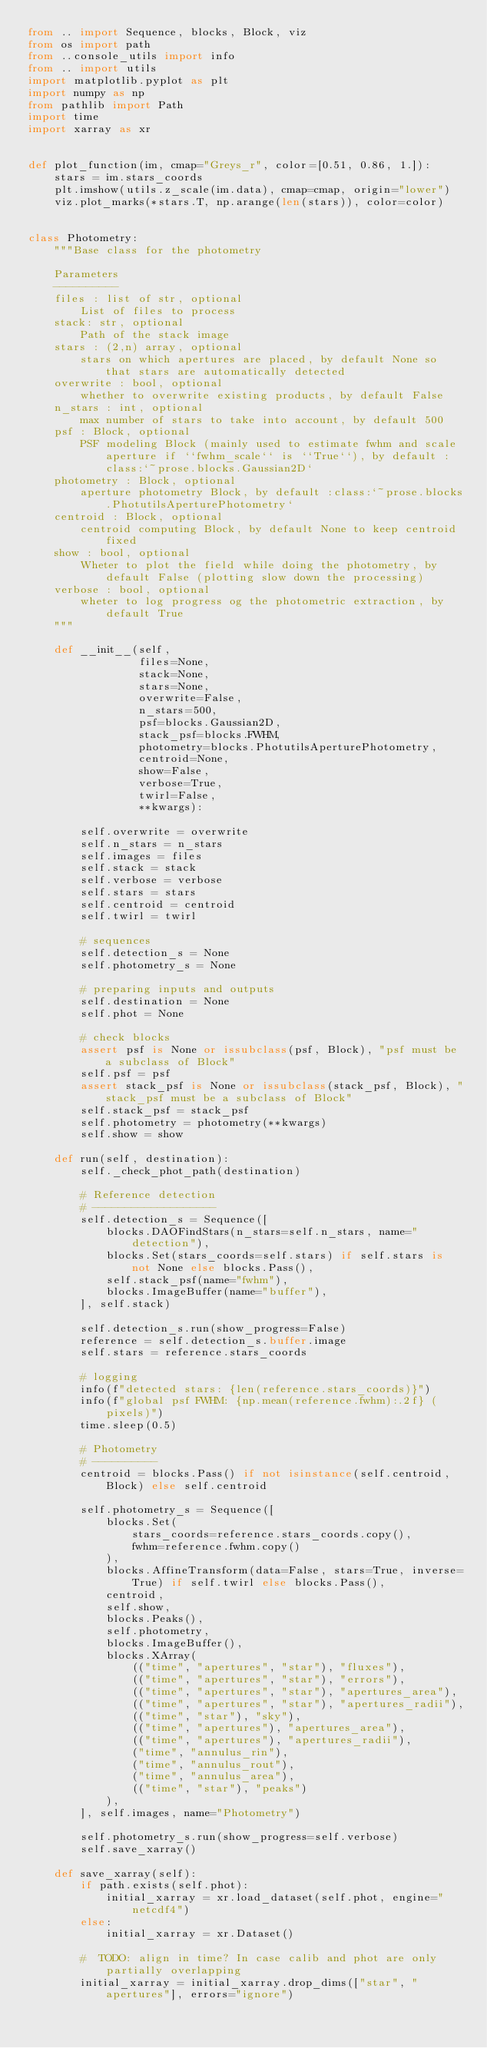Convert code to text. <code><loc_0><loc_0><loc_500><loc_500><_Python_>from .. import Sequence, blocks, Block, viz
from os import path
from ..console_utils import info
from .. import utils
import matplotlib.pyplot as plt
import numpy as np
from pathlib import Path
import time
import xarray as xr


def plot_function(im, cmap="Greys_r", color=[0.51, 0.86, 1.]):
    stars = im.stars_coords
    plt.imshow(utils.z_scale(im.data), cmap=cmap, origin="lower")
    viz.plot_marks(*stars.T, np.arange(len(stars)), color=color)


class Photometry:
    """Base class for the photometry

    Parameters
    ----------
    files : list of str, optional
        List of files to process
    stack: str, optional
        Path of the stack image
    stars : (2,n) array, optional
        stars on which apertures are placed, by default None so that stars are automatically detected
    overwrite : bool, optional
        whether to overwrite existing products, by default False
    n_stars : int, optional
        max number of stars to take into account, by default 500
    psf : Block, optional
        PSF modeling Block (mainly used to estimate fwhm and scale aperture if ``fwhm_scale`` is ``True``), by default :class:`~prose.blocks.Gaussian2D`
    photometry : Block, optional
        aperture photometry Block, by default :class:`~prose.blocks.PhotutilsAperturePhotometry`
    centroid : Block, optional
        centroid computing Block, by default None to keep centroid fixed
    show : bool, optional
        Wheter to plot the field while doing the photometry, by default False (plotting slow down the processing)
    verbose : bool, optional
        wheter to log progress og the photometric extraction, by default True
    """

    def __init__(self,
                 files=None,
                 stack=None,
                 stars=None,
                 overwrite=False,
                 n_stars=500,
                 psf=blocks.Gaussian2D,
                 stack_psf=blocks.FWHM,
                 photometry=blocks.PhotutilsAperturePhotometry,
                 centroid=None,
                 show=False,
                 verbose=True,
                 twirl=False,
                 **kwargs):

        self.overwrite = overwrite
        self.n_stars = n_stars
        self.images = files
        self.stack = stack
        self.verbose = verbose
        self.stars = stars
        self.centroid = centroid
        self.twirl = twirl

        # sequences
        self.detection_s = None
        self.photometry_s = None

        # preparing inputs and outputs
        self.destination = None
        self.phot = None

        # check blocks
        assert psf is None or issubclass(psf, Block), "psf must be a subclass of Block"
        self.psf = psf
        assert stack_psf is None or issubclass(stack_psf, Block), "stack_psf must be a subclass of Block"
        self.stack_psf = stack_psf
        self.photometry = photometry(**kwargs)
        self.show = show

    def run(self, destination):
        self._check_phot_path(destination)

        # Reference detection
        # -------------------
        self.detection_s = Sequence([
            blocks.DAOFindStars(n_stars=self.n_stars, name="detection"),
            blocks.Set(stars_coords=self.stars) if self.stars is not None else blocks.Pass(),
            self.stack_psf(name="fwhm"),
            blocks.ImageBuffer(name="buffer"),
        ], self.stack)

        self.detection_s.run(show_progress=False)
        reference = self.detection_s.buffer.image
        self.stars = reference.stars_coords

        # logging
        info(f"detected stars: {len(reference.stars_coords)}")
        info(f"global psf FWHM: {np.mean(reference.fwhm):.2f} (pixels)")
        time.sleep(0.5)

        # Photometry
        # ----------
        centroid = blocks.Pass() if not isinstance(self.centroid, Block) else self.centroid

        self.photometry_s = Sequence([
            blocks.Set(
                stars_coords=reference.stars_coords.copy(),
                fwhm=reference.fwhm.copy()
            ),
            blocks.AffineTransform(data=False, stars=True, inverse=True) if self.twirl else blocks.Pass(),
            centroid,
            self.show,
            blocks.Peaks(),
            self.photometry,
            blocks.ImageBuffer(),
            blocks.XArray(
                (("time", "apertures", "star"), "fluxes"),
                (("time", "apertures", "star"), "errors"),
                (("time", "apertures", "star"), "apertures_area"),
                (("time", "apertures", "star"), "apertures_radii"),
                (("time", "star"), "sky"),
                (("time", "apertures"), "apertures_area"),
                (("time", "apertures"), "apertures_radii"),
                ("time", "annulus_rin"),
                ("time", "annulus_rout"),
                ("time", "annulus_area"),
                (("time", "star"), "peaks")
            ),
        ], self.images, name="Photometry")

        self.photometry_s.run(show_progress=self.verbose)
        self.save_xarray()

    def save_xarray(self):
        if path.exists(self.phot):
            initial_xarray = xr.load_dataset(self.phot, engine="netcdf4")
        else:
            initial_xarray = xr.Dataset()

        #  TODO: align in time? In case calib and phot are only partially overlapping
        initial_xarray = initial_xarray.drop_dims(["star", "apertures"], errors="ignore")</code> 